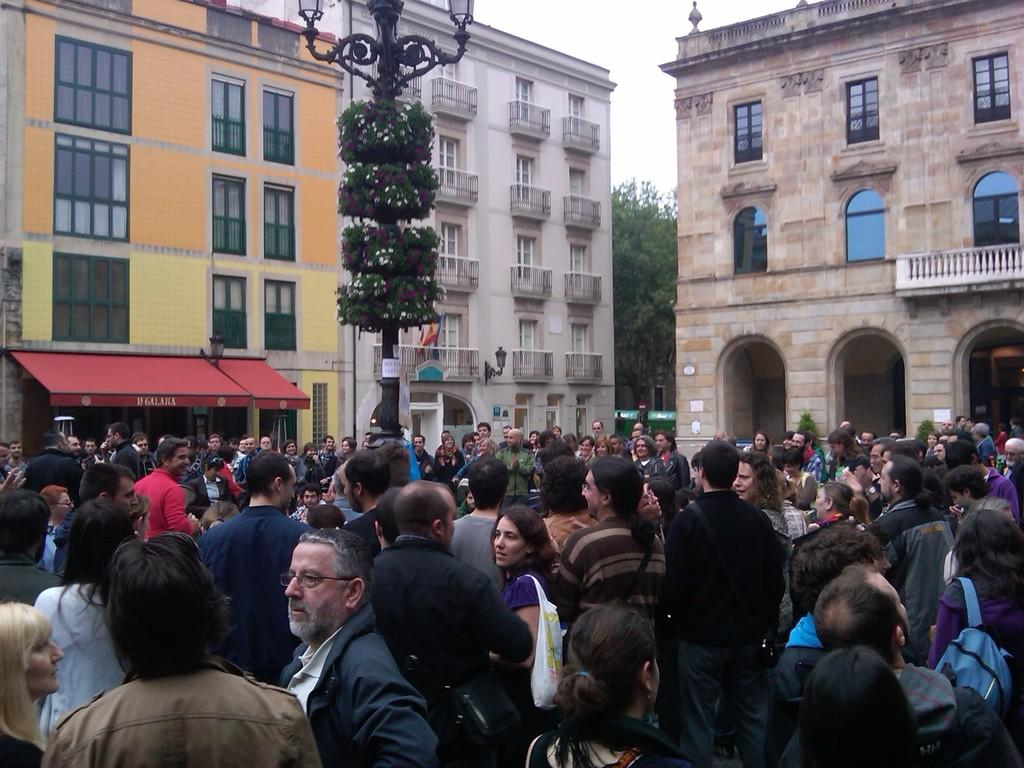What is the main feature of the image? The main feature of the image is a huge crowd. What structures can be seen in the image besides the crowd? There are three buildings in the image. What is the purpose of the pole in the image? The pole in the image has two lights attached to it. How many lights are there on the pole? There are two lights attached to the pole. How does the crowd's temper affect the lights on the pole? The image does not show any indication of the crowd's temper, and there is no connection between the crowd's temper and the lights on the pole. 